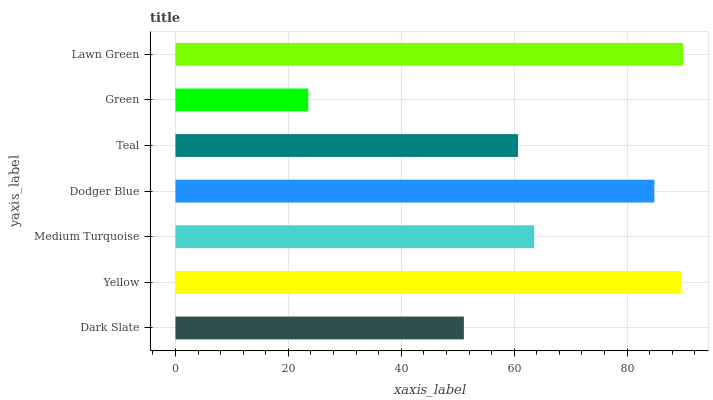Is Green the minimum?
Answer yes or no. Yes. Is Lawn Green the maximum?
Answer yes or no. Yes. Is Yellow the minimum?
Answer yes or no. No. Is Yellow the maximum?
Answer yes or no. No. Is Yellow greater than Dark Slate?
Answer yes or no. Yes. Is Dark Slate less than Yellow?
Answer yes or no. Yes. Is Dark Slate greater than Yellow?
Answer yes or no. No. Is Yellow less than Dark Slate?
Answer yes or no. No. Is Medium Turquoise the high median?
Answer yes or no. Yes. Is Medium Turquoise the low median?
Answer yes or no. Yes. Is Green the high median?
Answer yes or no. No. Is Green the low median?
Answer yes or no. No. 